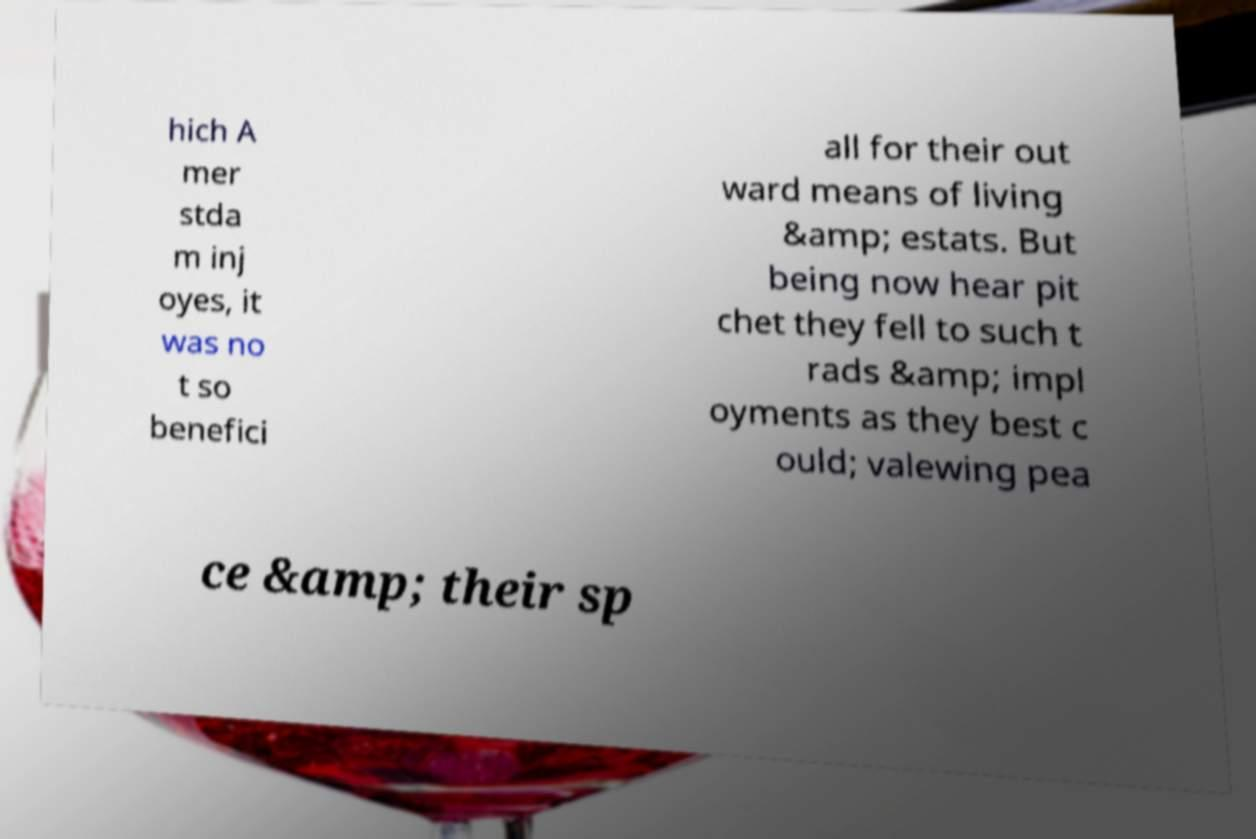What messages or text are displayed in this image? I need them in a readable, typed format. hich A mer stda m inj oyes, it was no t so benefici all for their out ward means of living &amp; estats. But being now hear pit chet they fell to such t rads &amp; impl oyments as they best c ould; valewing pea ce &amp; their sp 